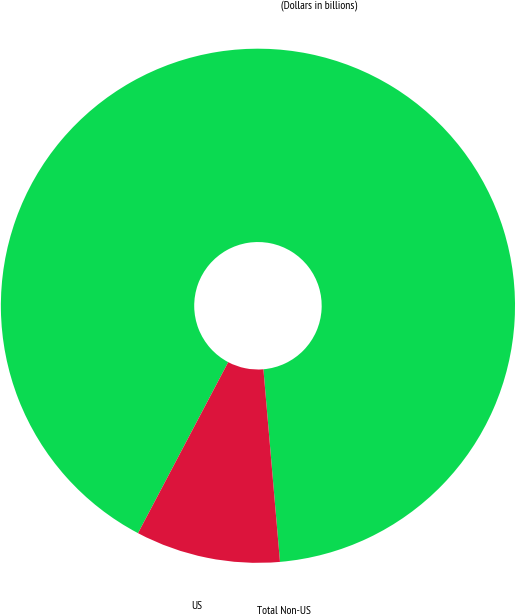<chart> <loc_0><loc_0><loc_500><loc_500><pie_chart><fcel>(Dollars in billions)<fcel>US<fcel>Total Non-US<nl><fcel>90.91%<fcel>9.09%<fcel>0.0%<nl></chart> 